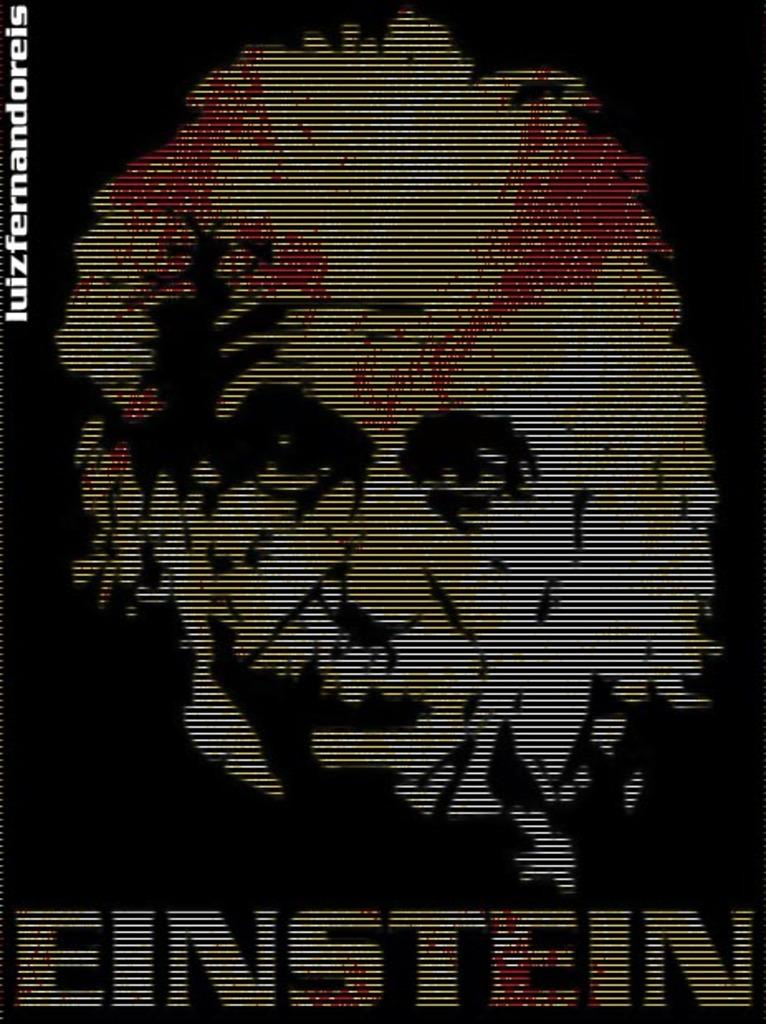<image>
Describe the image concisely. Photo of Albert Einstein with the word "EINSTEIN" on the bottom. 